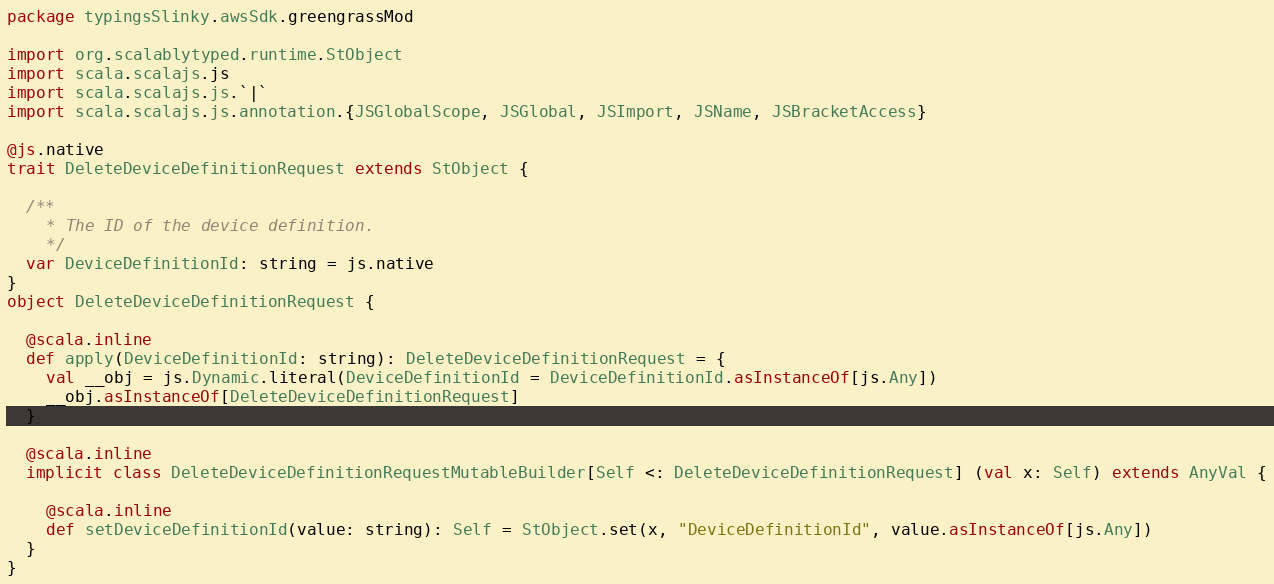Convert code to text. <code><loc_0><loc_0><loc_500><loc_500><_Scala_>package typingsSlinky.awsSdk.greengrassMod

import org.scalablytyped.runtime.StObject
import scala.scalajs.js
import scala.scalajs.js.`|`
import scala.scalajs.js.annotation.{JSGlobalScope, JSGlobal, JSImport, JSName, JSBracketAccess}

@js.native
trait DeleteDeviceDefinitionRequest extends StObject {
  
  /**
    * The ID of the device definition.
    */
  var DeviceDefinitionId: string = js.native
}
object DeleteDeviceDefinitionRequest {
  
  @scala.inline
  def apply(DeviceDefinitionId: string): DeleteDeviceDefinitionRequest = {
    val __obj = js.Dynamic.literal(DeviceDefinitionId = DeviceDefinitionId.asInstanceOf[js.Any])
    __obj.asInstanceOf[DeleteDeviceDefinitionRequest]
  }
  
  @scala.inline
  implicit class DeleteDeviceDefinitionRequestMutableBuilder[Self <: DeleteDeviceDefinitionRequest] (val x: Self) extends AnyVal {
    
    @scala.inline
    def setDeviceDefinitionId(value: string): Self = StObject.set(x, "DeviceDefinitionId", value.asInstanceOf[js.Any])
  }
}
</code> 